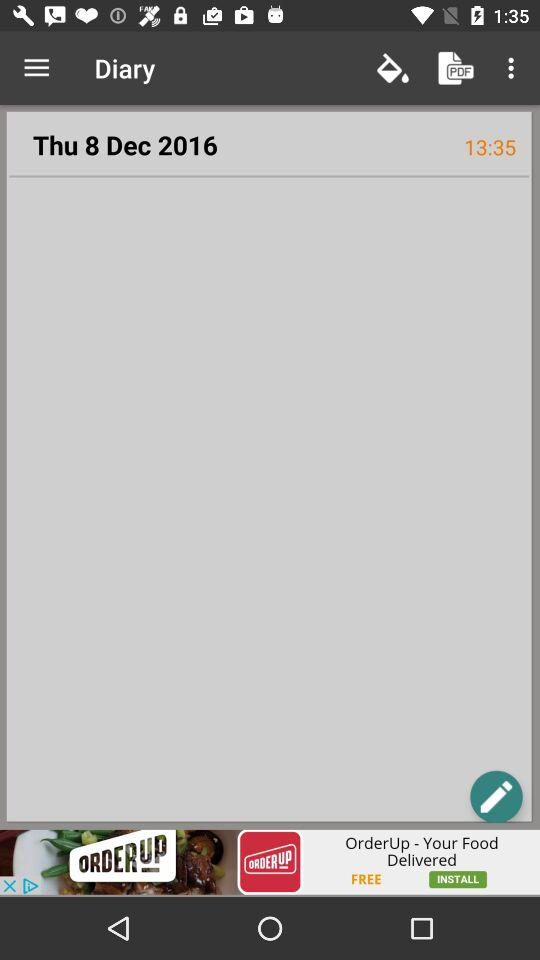What is the mentioned date and time? The mentioned date and time are Thursday, December 8, 2016 and 1:35 PM. 